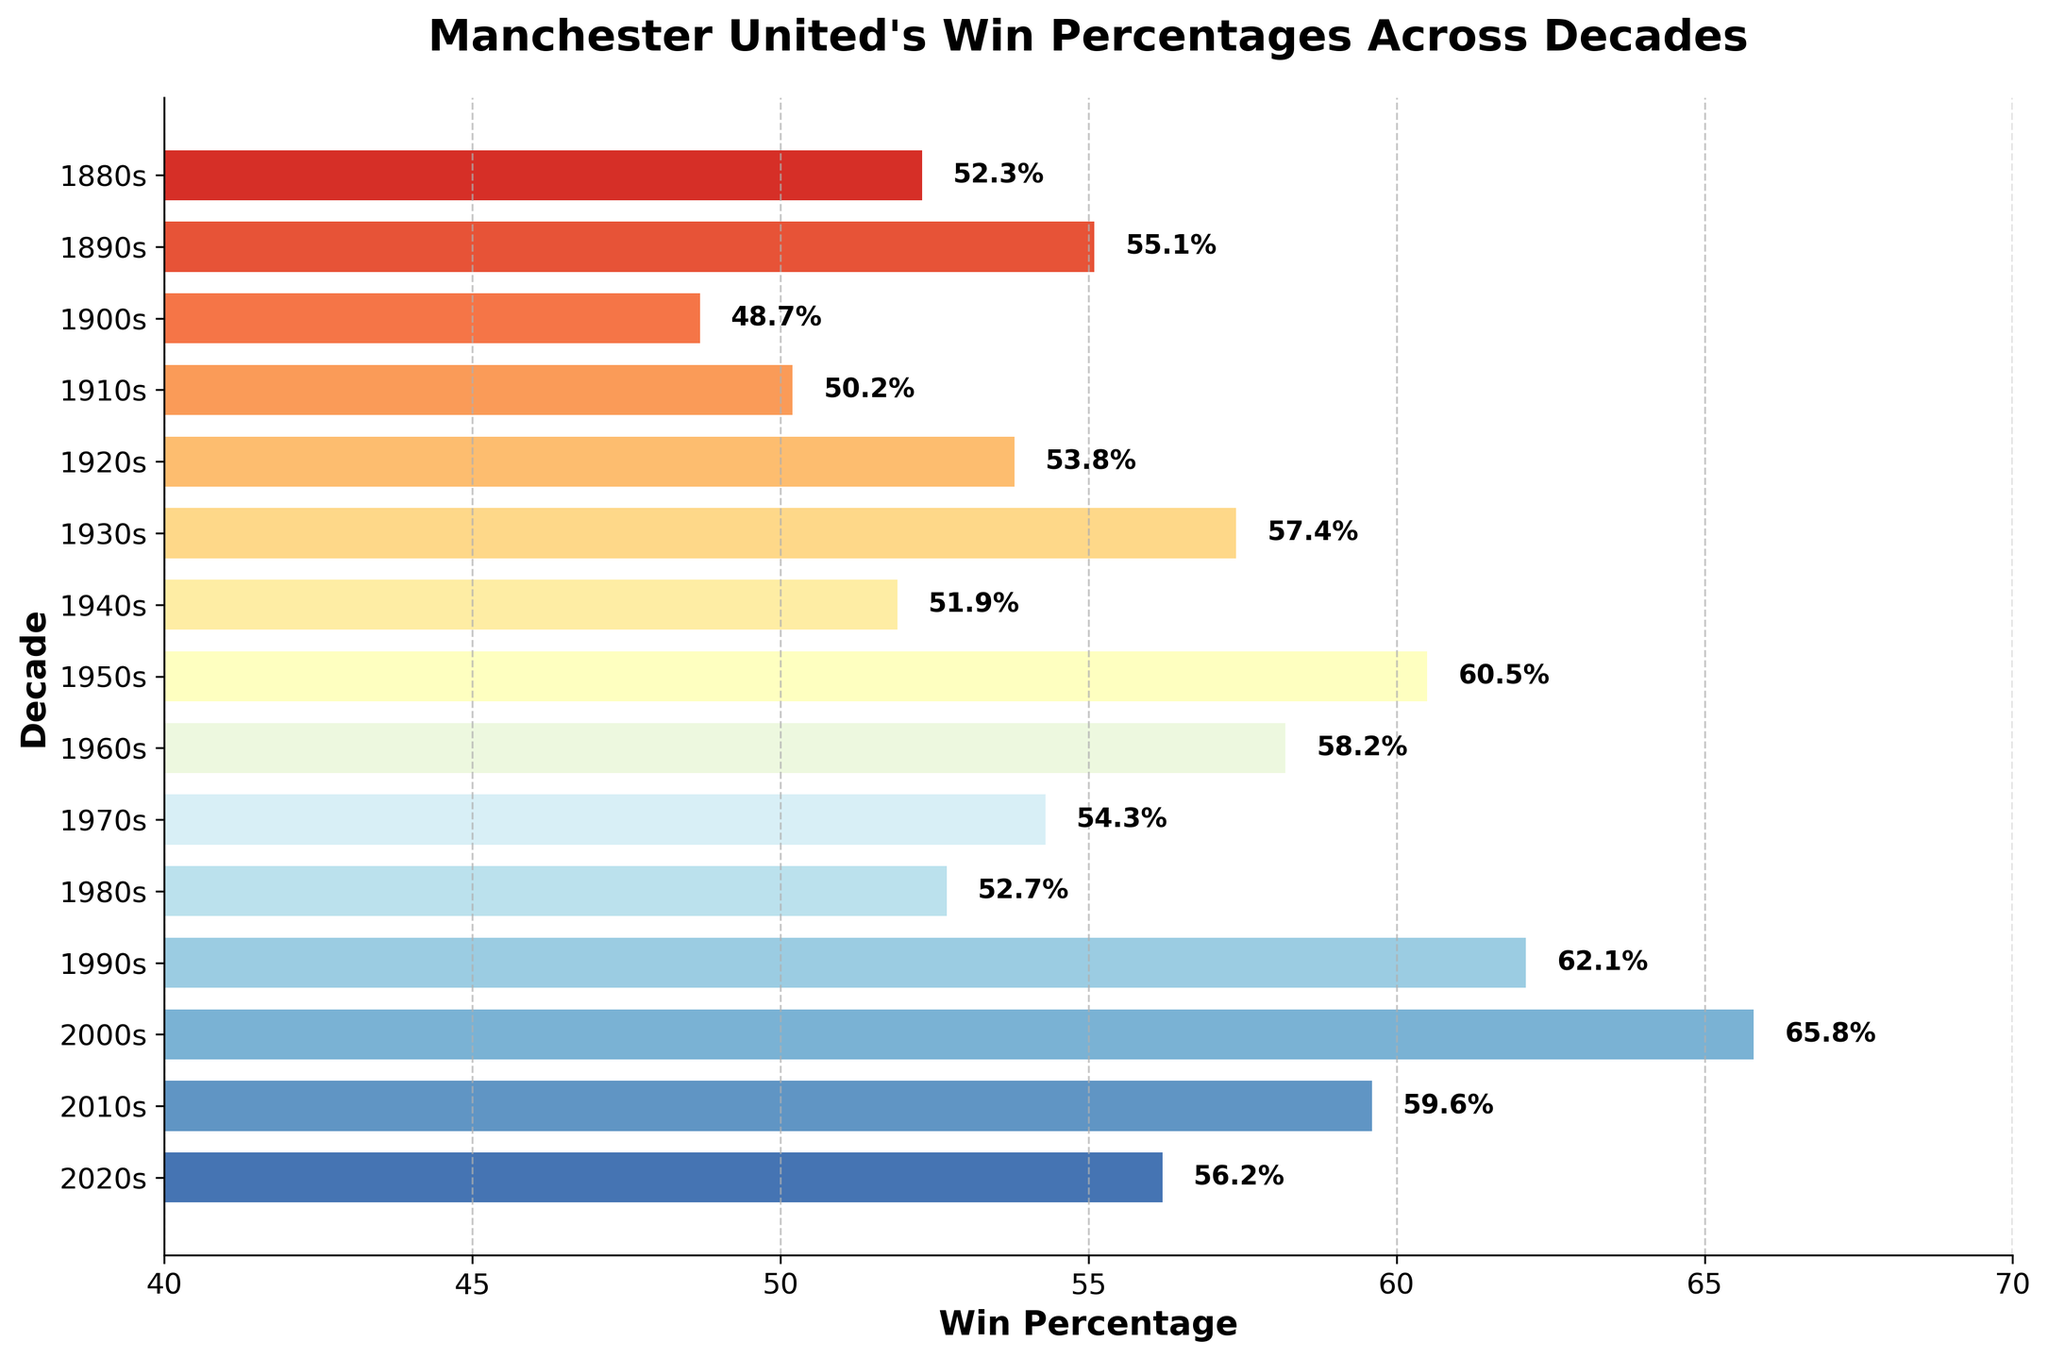What is the highest win percentage displayed in the chart? The highest win percentage is the bar with the largest width. By looking at the chart, the longest bar corresponds to the percentage with the text "65.8%".
Answer: 65.8% What decade had the lowest win percentage? The shortest bar represents the decade with the lowest win percentage. The shortest bar corresponds to the percentage with the text "48.7%" which is the 1900s.
Answer: 1900s Which decade had a higher win percentage, the 1920s or the 1980s? By comparing the lengths of the bars labeled "1920s" and "1980s", we see that the 1920s bar is longer than the 1980s bar. The percentages confirm: 53.8% vs. 52.7%.
Answer: 1920s How many decades had a win percentage greater than 60%? To determine this, count the number of bars with widths greater than 60%. The bars for the 1950s, 1990s, and 2000s have widths above 60%.
Answer: 3 What is the difference in win percentage between the 1930s and the 2010s? Find the values for both decades (1930s: 57.4%, 2010s: 59.6%) and subtract them. The difference is 59.6% - 57.4%.
Answer: 2.2% What's the median win percentage shown in the chart? To find the median, list all win percentages and find the middle value. The values are: 48.7, 50.2, 51.9, 52.3, 52.7, 53.8, 54.3, 55.1, 56.2, 57.4, 58.2, 59.6, 60.5, 62.1, 65.8. The middle value (8th) is 54.3%.
Answer: 54.3% Which decade showed the greatest improvement in win percentage from the previous decade? Calculate the difference between consecutive decades. The biggest positive difference is between the 1940s (51.9%) and 1950s (60.5%) with an increase of 8.6%.
Answer: 1950s Are there more decades with win percentages above or below 55%? Count the number of decades with percentages above 55% (7) and below 55% (8). There are more below.
Answer: below What is the average win percentage across the displayed decades? Sum all win percentages and divide by the number of decades. The sum is 848.2%. Dividing by 15 decades gives an average of ~56.5%.
Answer: ~56.5% What is the range of win percentages shown? The range is the difference between the highest (65.8%) and the lowest (48.7%) percentages. The range is 65.8 - 48.7.
Answer: 17.1% 